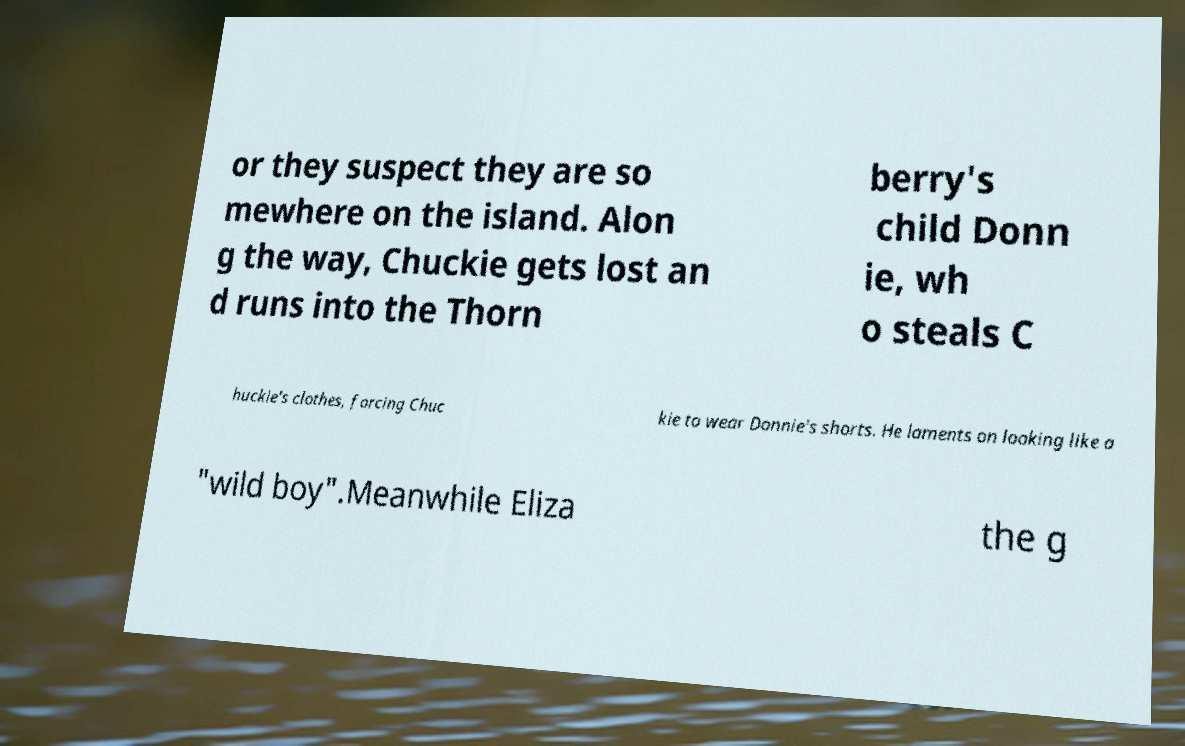Could you assist in decoding the text presented in this image and type it out clearly? or they suspect they are so mewhere on the island. Alon g the way, Chuckie gets lost an d runs into the Thorn berry's child Donn ie, wh o steals C huckie's clothes, forcing Chuc kie to wear Donnie's shorts. He laments on looking like a "wild boy".Meanwhile Eliza the g 